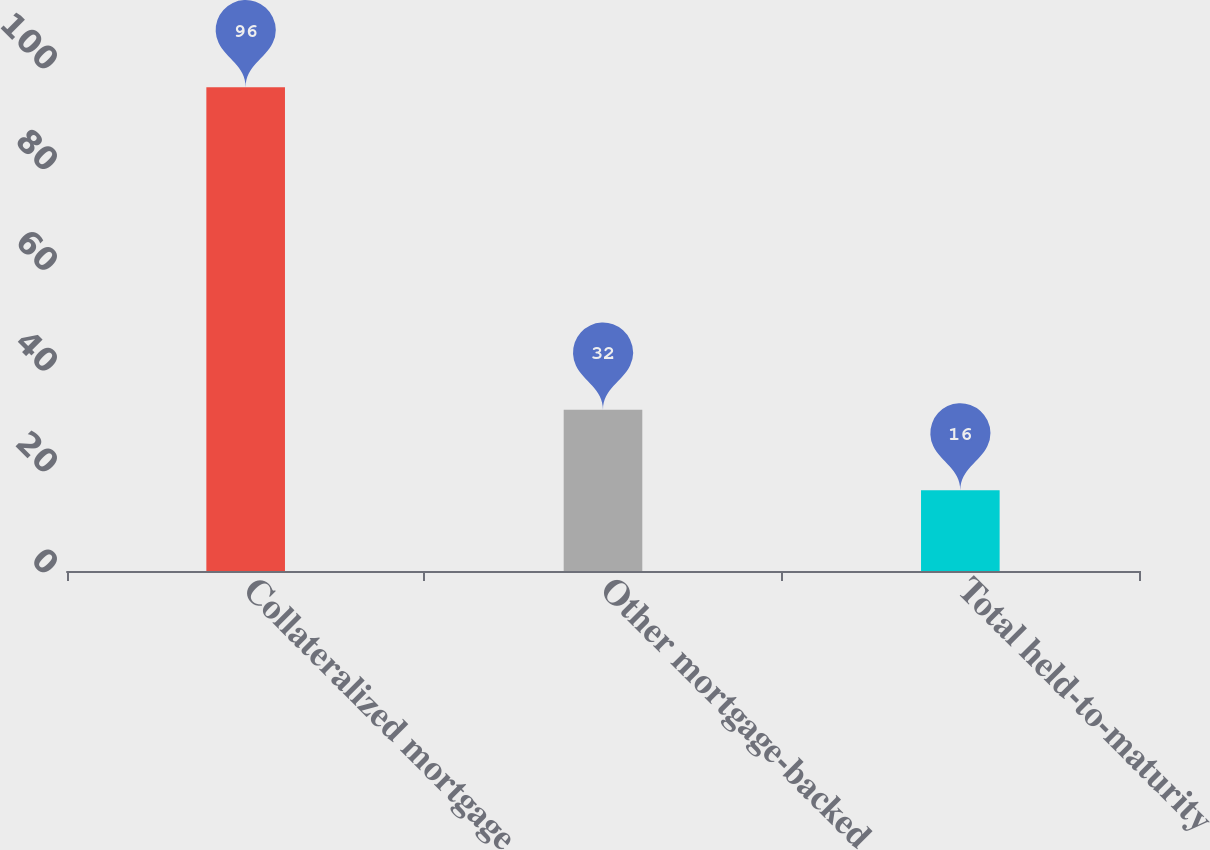Convert chart. <chart><loc_0><loc_0><loc_500><loc_500><bar_chart><fcel>Collateralized mortgage<fcel>Other mortgage-backed<fcel>Total held-to-maturity<nl><fcel>96<fcel>32<fcel>16<nl></chart> 